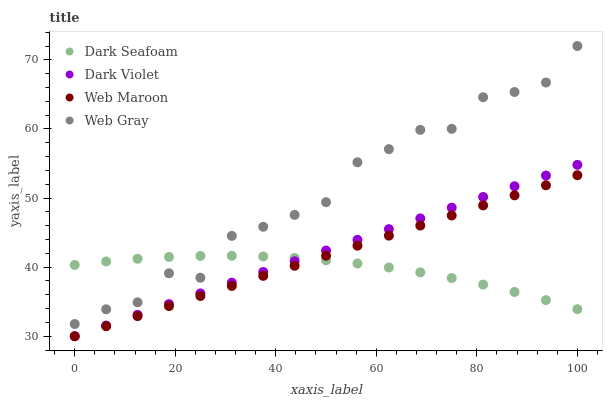Does Dark Seafoam have the minimum area under the curve?
Answer yes or no. Yes. Does Web Gray have the maximum area under the curve?
Answer yes or no. Yes. Does Web Maroon have the minimum area under the curve?
Answer yes or no. No. Does Web Maroon have the maximum area under the curve?
Answer yes or no. No. Is Dark Violet the smoothest?
Answer yes or no. Yes. Is Web Gray the roughest?
Answer yes or no. Yes. Is Web Maroon the smoothest?
Answer yes or no. No. Is Web Maroon the roughest?
Answer yes or no. No. Does Web Maroon have the lowest value?
Answer yes or no. Yes. Does Web Gray have the lowest value?
Answer yes or no. No. Does Web Gray have the highest value?
Answer yes or no. Yes. Does Web Maroon have the highest value?
Answer yes or no. No. Is Web Maroon less than Web Gray?
Answer yes or no. Yes. Is Web Gray greater than Web Maroon?
Answer yes or no. Yes. Does Dark Violet intersect Dark Seafoam?
Answer yes or no. Yes. Is Dark Violet less than Dark Seafoam?
Answer yes or no. No. Is Dark Violet greater than Dark Seafoam?
Answer yes or no. No. Does Web Maroon intersect Web Gray?
Answer yes or no. No. 